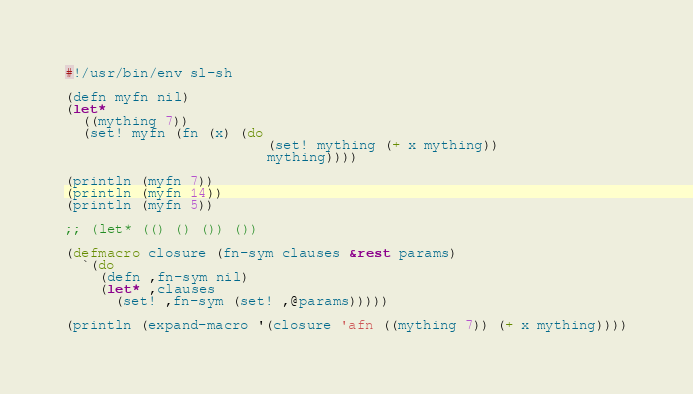<code> <loc_0><loc_0><loc_500><loc_500><_Lisp_>#!/usr/bin/env sl-sh

(defn myfn nil)
(let*
  ((mything 7))
  (set! myfn (fn (x) (do
                        (set! mything (+ x mything))
                        mything))))

(println (myfn 7))
(println (myfn 14))
(println (myfn 5))

;; (let* (() () ()) ())

(defmacro closure (fn-sym clauses &rest params)
  `(do
    (defn ,fn-sym nil)
    (let* ,clauses
      (set! ,fn-sym (set! ,@params)))))

(println (expand-macro '(closure 'afn ((mything 7)) (+ x mything))))


</code> 